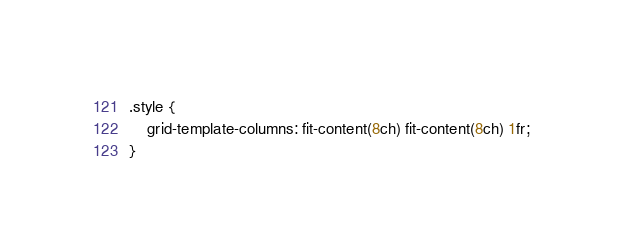<code> <loc_0><loc_0><loc_500><loc_500><_CSS_>.style {
	grid-template-columns: fit-content(8ch) fit-content(8ch) 1fr;
}
</code> 